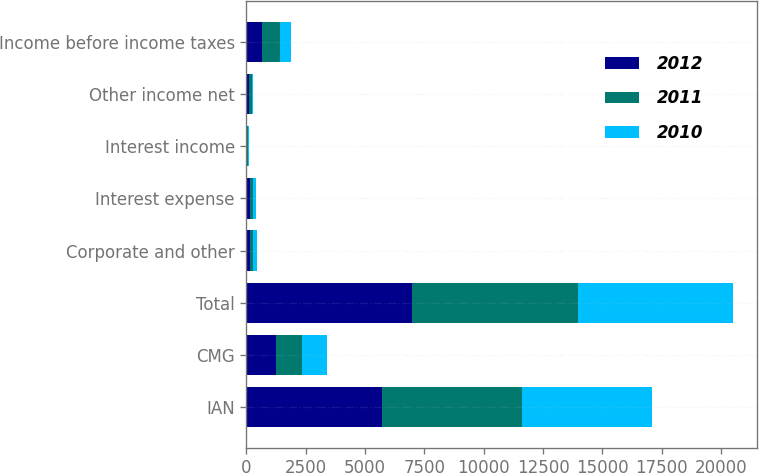Convert chart. <chart><loc_0><loc_0><loc_500><loc_500><stacked_bar_chart><ecel><fcel>IAN<fcel>CMG<fcel>Total<fcel>Corporate and other<fcel>Interest expense<fcel>Interest income<fcel>Other income net<fcel>Income before income taxes<nl><fcel>2012<fcel>5728.5<fcel>1227.7<fcel>6956.2<fcel>137.3<fcel>133.5<fcel>29.5<fcel>100.5<fcel>674.8<nl><fcel>2011<fcel>5891.8<fcel>1122.8<fcel>7014.6<fcel>142<fcel>136.8<fcel>37.8<fcel>150.2<fcel>738.4<nl><fcel>2010<fcel>5468.4<fcel>1038.9<fcel>6507.3<fcel>145.3<fcel>139.7<fcel>28.7<fcel>12.9<fcel>450.6<nl></chart> 